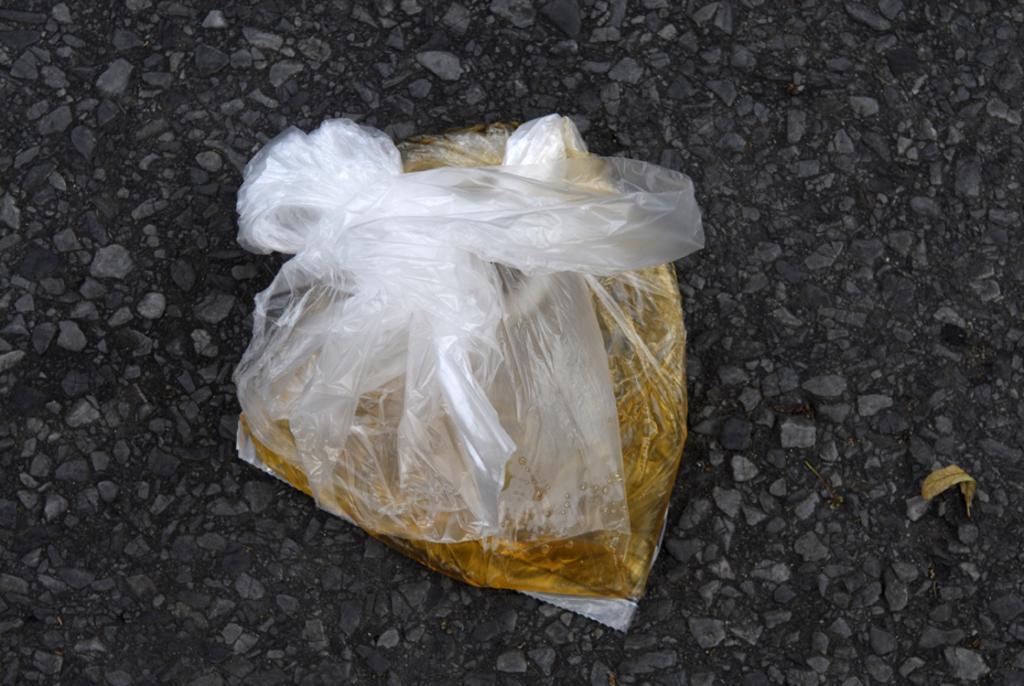Describe this image in one or two sentences. In this image we can see some golden color liquid in a transparent polythene cover is kept on the road and one dry leaf is there. 